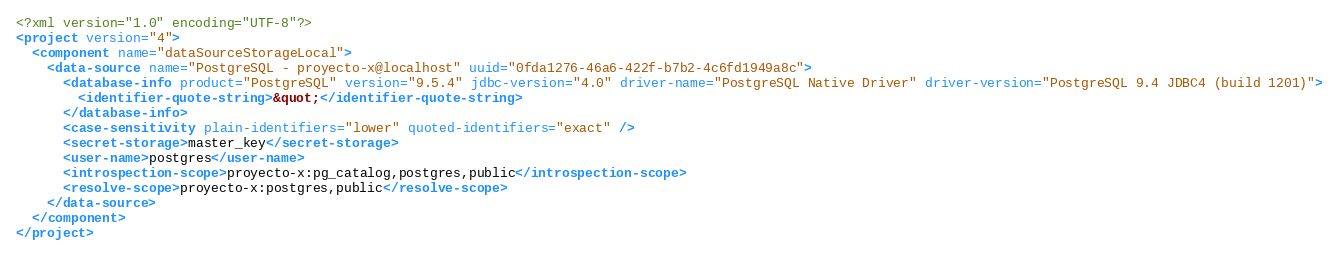Convert code to text. <code><loc_0><loc_0><loc_500><loc_500><_XML_><?xml version="1.0" encoding="UTF-8"?>
<project version="4">
  <component name="dataSourceStorageLocal">
    <data-source name="PostgreSQL - proyecto-x@localhost" uuid="0fda1276-46a6-422f-b7b2-4c6fd1949a8c">
      <database-info product="PostgreSQL" version="9.5.4" jdbc-version="4.0" driver-name="PostgreSQL Native Driver" driver-version="PostgreSQL 9.4 JDBC4 (build 1201)">
        <identifier-quote-string>&quot;</identifier-quote-string>
      </database-info>
      <case-sensitivity plain-identifiers="lower" quoted-identifiers="exact" />
      <secret-storage>master_key</secret-storage>
      <user-name>postgres</user-name>
      <introspection-scope>proyecto-x:pg_catalog,postgres,public</introspection-scope>
      <resolve-scope>proyecto-x:postgres,public</resolve-scope>
    </data-source>
  </component>
</project></code> 